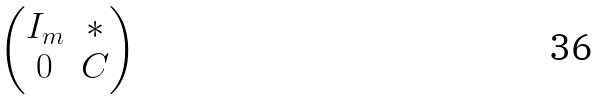Convert formula to latex. <formula><loc_0><loc_0><loc_500><loc_500>\begin{pmatrix} I _ { m } & * \\ 0 & C \end{pmatrix}</formula> 